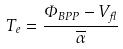Convert formula to latex. <formula><loc_0><loc_0><loc_500><loc_500>T _ { e } = \frac { \Phi _ { B P P } - V _ { f l } } { \overline { \alpha } }</formula> 